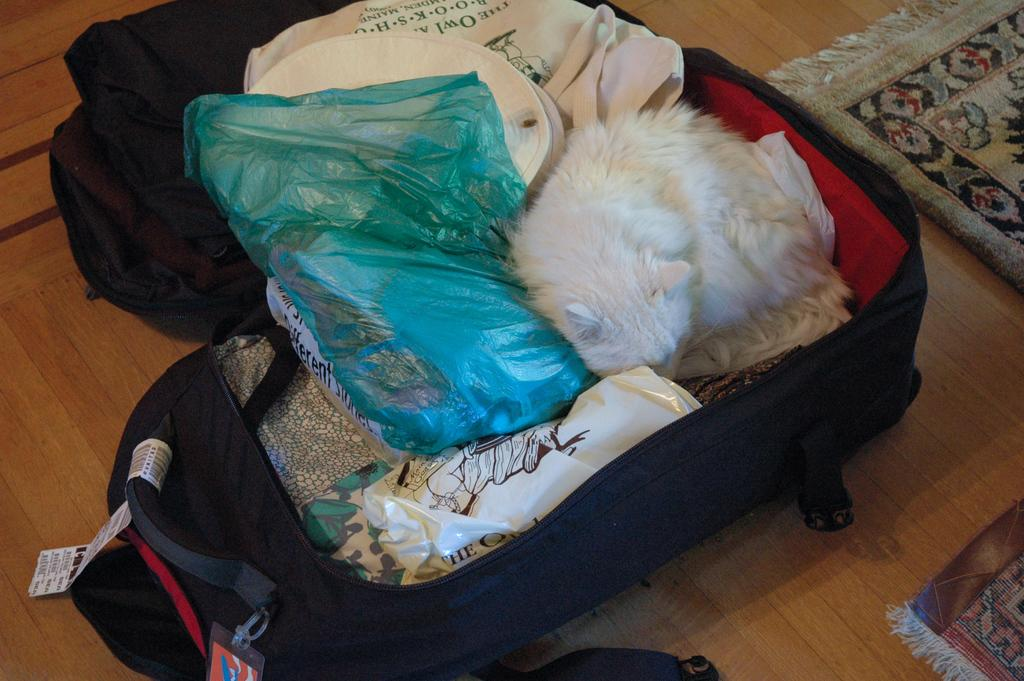What is on the ground in the image? There is a bag on the ground. What is inside the bag? The bag contains clothes and a cover. Is there any living creature inside the bag? Yes, there is a cat in the bag. What is located beside the bag? There is a mat beside the bag. How many books are stacked on the cat in the image? There are no books present in the image, so it is not possible to determine how many books might be stacked on the cat. 